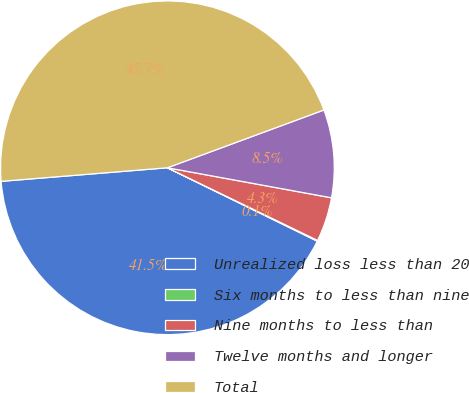<chart> <loc_0><loc_0><loc_500><loc_500><pie_chart><fcel>Unrealized loss less than 20<fcel>Six months to less than nine<fcel>Nine months to less than<fcel>Twelve months and longer<fcel>Total<nl><fcel>41.45%<fcel>0.08%<fcel>4.29%<fcel>8.51%<fcel>45.66%<nl></chart> 